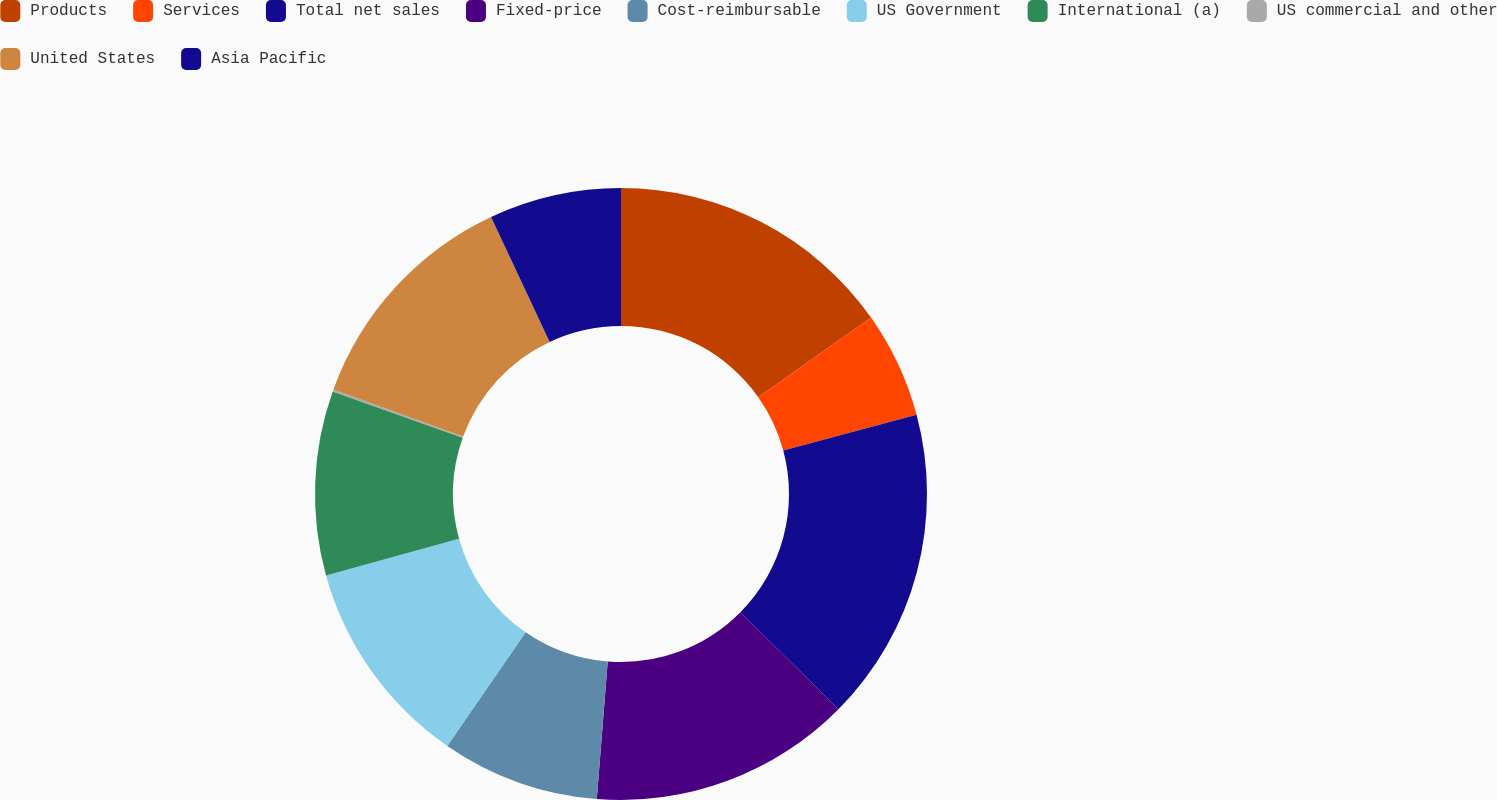<chart> <loc_0><loc_0><loc_500><loc_500><pie_chart><fcel>Products<fcel>Services<fcel>Total net sales<fcel>Fixed-price<fcel>Cost-reimbursable<fcel>US Government<fcel>International (a)<fcel>US commercial and other<fcel>United States<fcel>Asia Pacific<nl><fcel>15.22%<fcel>5.61%<fcel>16.59%<fcel>13.84%<fcel>8.35%<fcel>11.1%<fcel>9.73%<fcel>0.11%<fcel>12.47%<fcel>6.98%<nl></chart> 